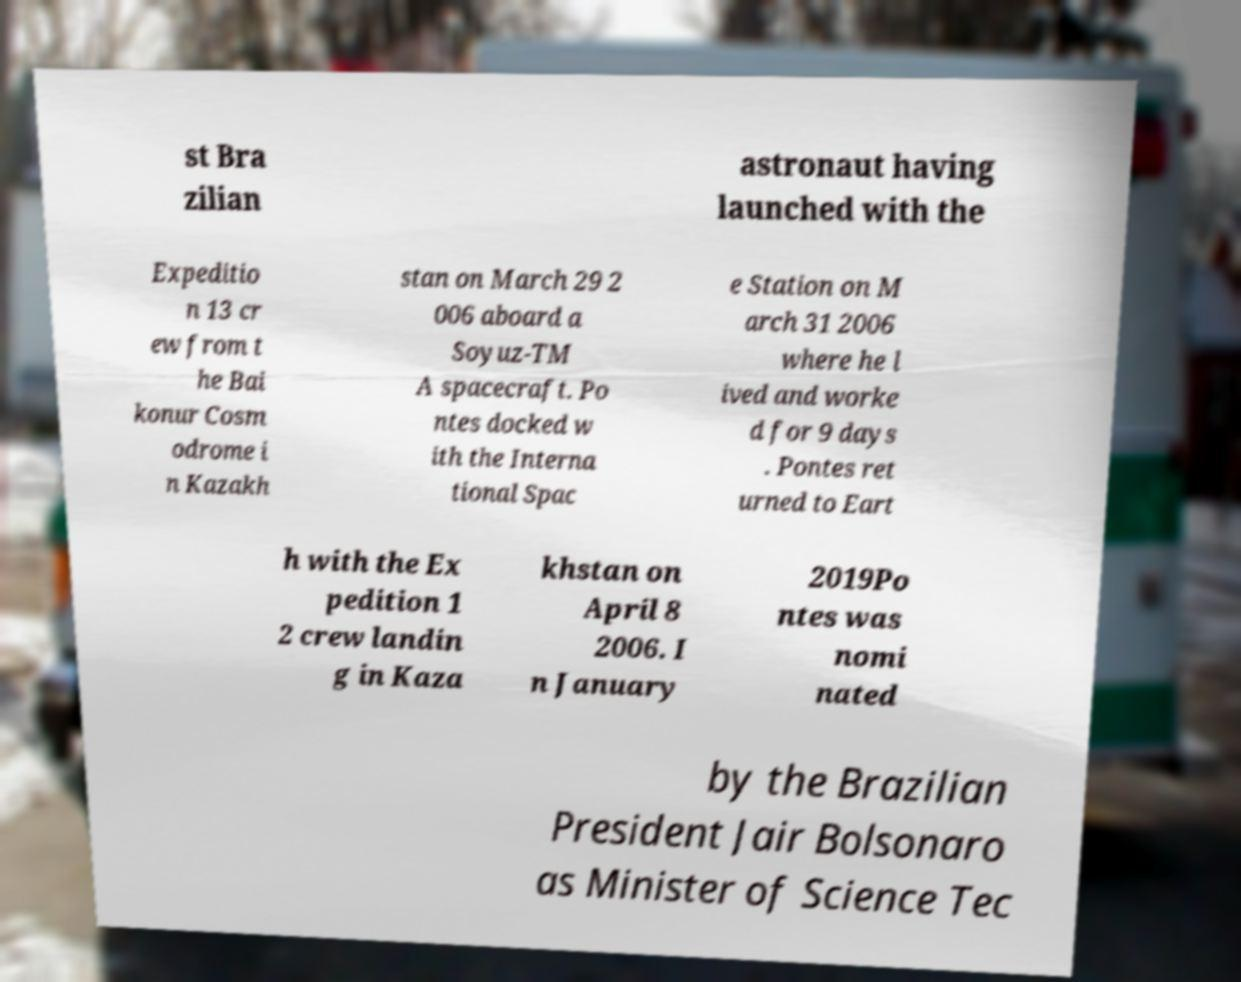There's text embedded in this image that I need extracted. Can you transcribe it verbatim? st Bra zilian astronaut having launched with the Expeditio n 13 cr ew from t he Bai konur Cosm odrome i n Kazakh stan on March 29 2 006 aboard a Soyuz-TM A spacecraft. Po ntes docked w ith the Interna tional Spac e Station on M arch 31 2006 where he l ived and worke d for 9 days . Pontes ret urned to Eart h with the Ex pedition 1 2 crew landin g in Kaza khstan on April 8 2006. I n January 2019Po ntes was nomi nated by the Brazilian President Jair Bolsonaro as Minister of Science Tec 